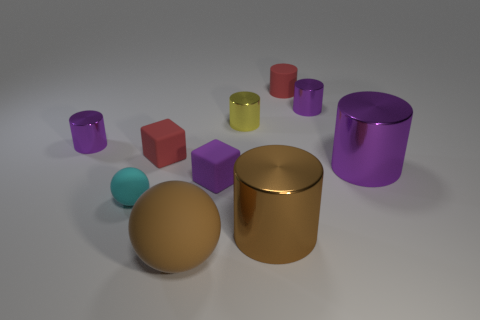Subtract all purple cylinders. How many were subtracted if there are1purple cylinders left? 2 Subtract all tiny red rubber cylinders. How many cylinders are left? 5 Subtract all purple cylinders. How many cylinders are left? 3 Subtract all yellow blocks. How many purple cylinders are left? 3 Subtract 2 cubes. How many cubes are left? 0 Subtract 1 brown balls. How many objects are left? 9 Subtract all blocks. How many objects are left? 8 Subtract all yellow balls. Subtract all cyan blocks. How many balls are left? 2 Subtract all big purple things. Subtract all small purple blocks. How many objects are left? 8 Add 4 big purple cylinders. How many big purple cylinders are left? 5 